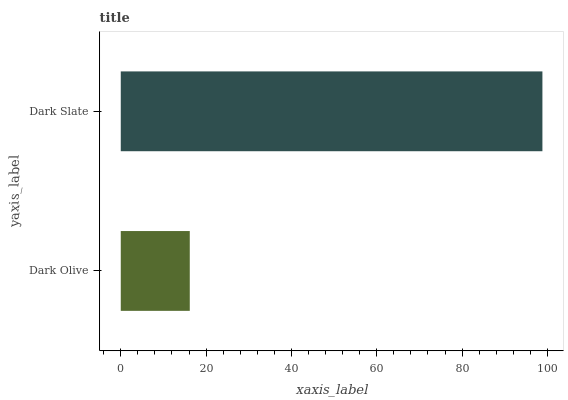Is Dark Olive the minimum?
Answer yes or no. Yes. Is Dark Slate the maximum?
Answer yes or no. Yes. Is Dark Slate the minimum?
Answer yes or no. No. Is Dark Slate greater than Dark Olive?
Answer yes or no. Yes. Is Dark Olive less than Dark Slate?
Answer yes or no. Yes. Is Dark Olive greater than Dark Slate?
Answer yes or no. No. Is Dark Slate less than Dark Olive?
Answer yes or no. No. Is Dark Slate the high median?
Answer yes or no. Yes. Is Dark Olive the low median?
Answer yes or no. Yes. Is Dark Olive the high median?
Answer yes or no. No. Is Dark Slate the low median?
Answer yes or no. No. 